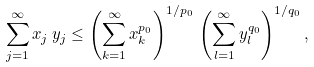Convert formula to latex. <formula><loc_0><loc_0><loc_500><loc_500>\sum _ { j = 1 } ^ { \infty } x _ { j } \, y _ { j } \leq \left ( \sum _ { k = 1 } ^ { \infty } x _ { k } ^ { p _ { 0 } } \right ) ^ { 1 / p _ { 0 } } \, \left ( \sum _ { l = 1 } ^ { \infty } y _ { l } ^ { q _ { 0 } } \right ) ^ { 1 / q _ { 0 } } ,</formula> 